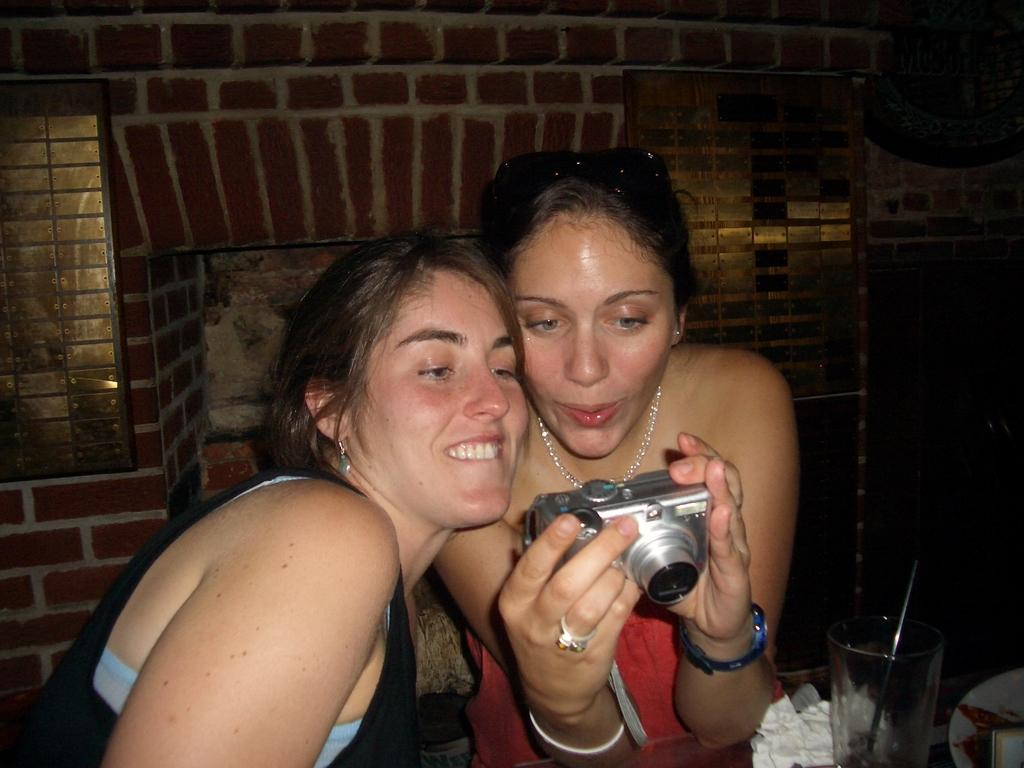How many people are in the image? There are two women in the image. What are the women doing in the image? The women are watching something in a camera. What object is in front of the women? There is a glass in front of the women. How many hands are visible in the image? There is no information about hands in the provided facts, so we cannot determine the number of hands visible in the image. 